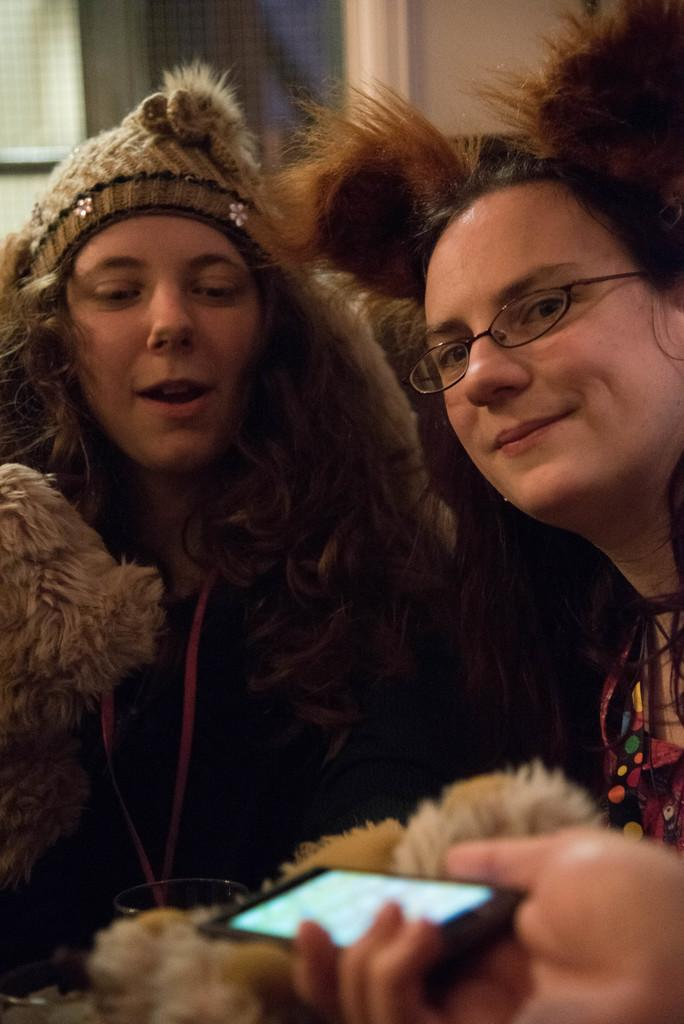How many women are in the image? There are two women in the image. What expression do the women have? The women are smiling. What can be seen in front of the women? There is a person's hand holding a mobile phone in front of the women. What is visible behind the women? There is a window visible behind the women. How many brothers are visible in the image? There are no brothers visible in the image. What type of body part is holding the mobile phone in the image? The hand holding the mobile phone is visible, but there is no specific body part mentioned in the facts. 